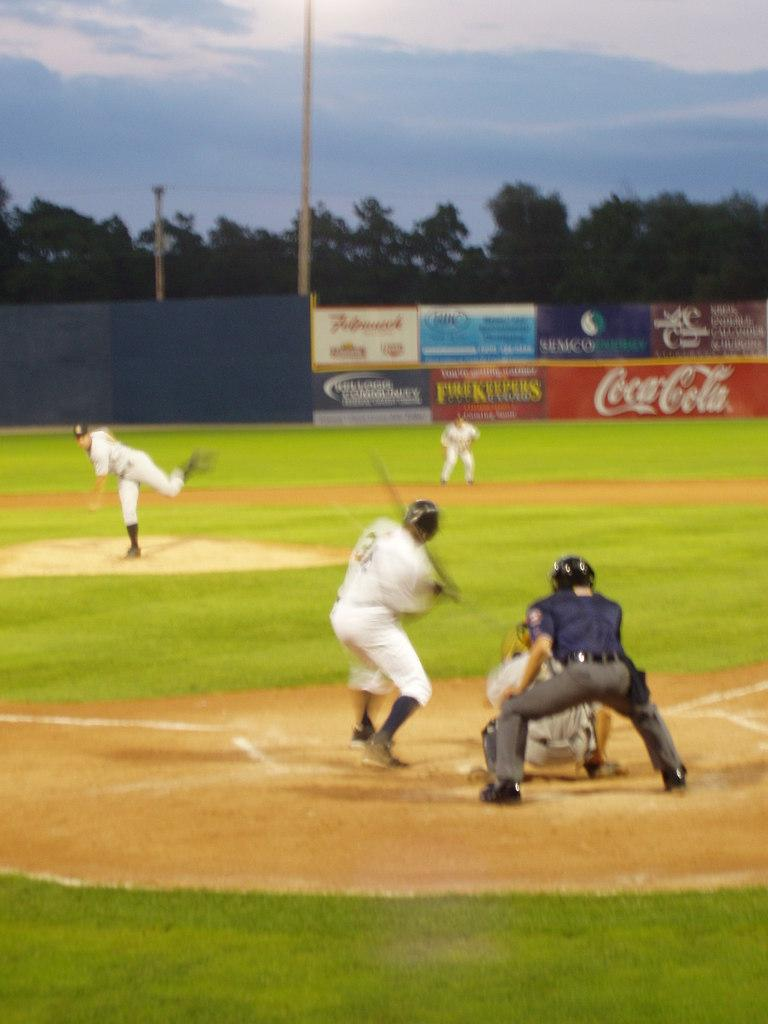Provide a one-sentence caption for the provided image. One of the sponsors in the baseball field is Coca-Cola. 